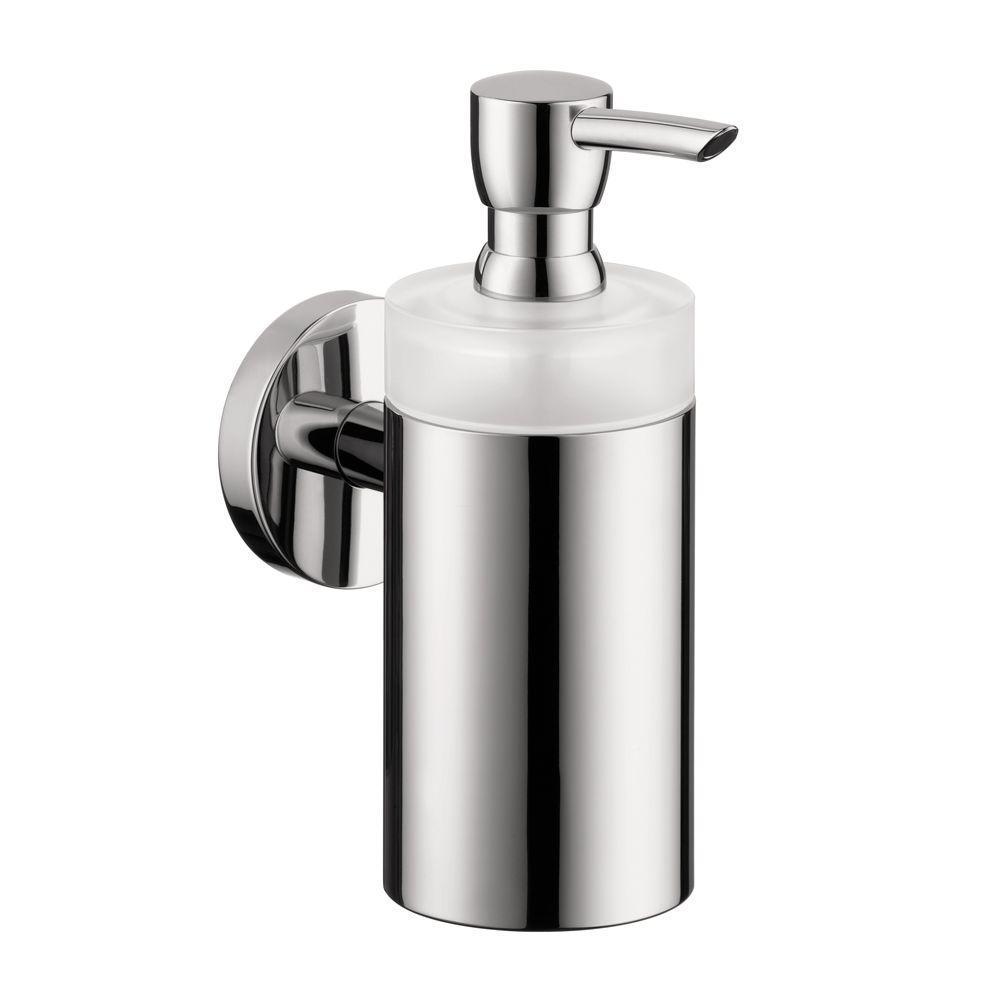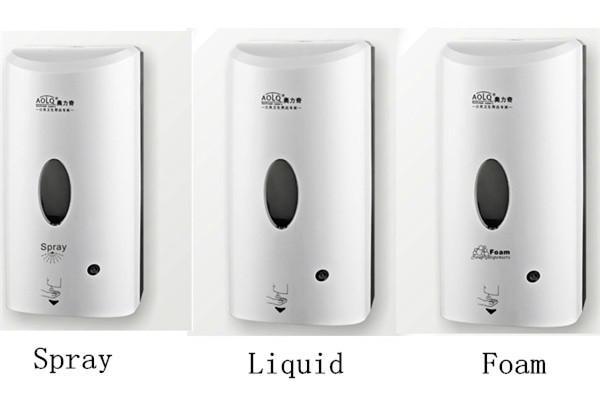The first image is the image on the left, the second image is the image on the right. Examine the images to the left and right. Is the description "An image features a cylindrical dispenser with chrome finish." accurate? Answer yes or no. Yes. The first image is the image on the left, the second image is the image on the right. Evaluate the accuracy of this statement regarding the images: "One of these is silver in color.". Is it true? Answer yes or no. Yes. 